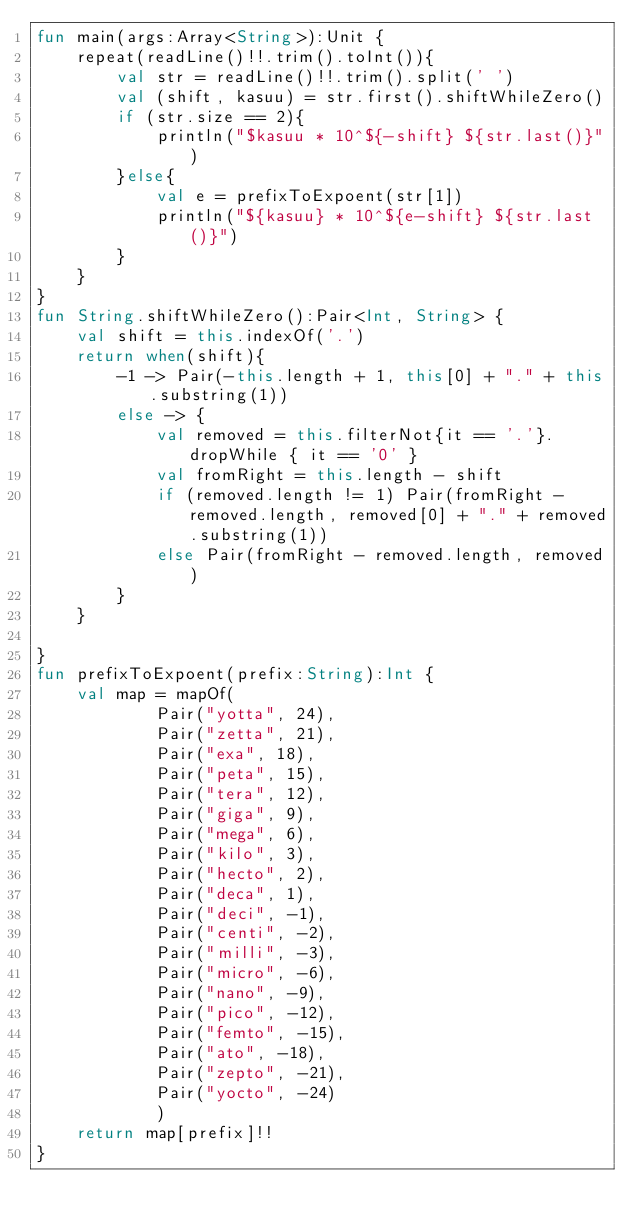Convert code to text. <code><loc_0><loc_0><loc_500><loc_500><_Kotlin_>fun main(args:Array<String>):Unit {
    repeat(readLine()!!.trim().toInt()){
        val str = readLine()!!.trim().split(' ')
        val (shift, kasuu) = str.first().shiftWhileZero()
        if (str.size == 2){
            println("$kasuu * 10^${-shift} ${str.last()}")
        }else{
            val e = prefixToExpoent(str[1])
            println("${kasuu} * 10^${e-shift} ${str.last()}")
        }
    }
}
fun String.shiftWhileZero():Pair<Int, String> {
    val shift = this.indexOf('.')
    return when(shift){
        -1 -> Pair(-this.length + 1, this[0] + "." + this.substring(1))
        else -> {
            val removed = this.filterNot{it == '.'}.dropWhile { it == '0' }
            val fromRight = this.length - shift
            if (removed.length != 1) Pair(fromRight - removed.length, removed[0] + "." + removed.substring(1))
            else Pair(fromRight - removed.length, removed)
        }
    }

}
fun prefixToExpoent(prefix:String):Int {
    val map = mapOf(
            Pair("yotta", 24),
            Pair("zetta", 21),
            Pair("exa", 18),
            Pair("peta", 15),
            Pair("tera", 12),
            Pair("giga", 9),
            Pair("mega", 6),
            Pair("kilo", 3),
            Pair("hecto", 2),
            Pair("deca", 1),
            Pair("deci", -1),
            Pair("centi", -2),
            Pair("milli", -3),
            Pair("micro", -6),
            Pair("nano", -9),
            Pair("pico", -12),
            Pair("femto", -15),
            Pair("ato", -18),
            Pair("zepto", -21),
            Pair("yocto", -24)
            )
    return map[prefix]!!
}
</code> 